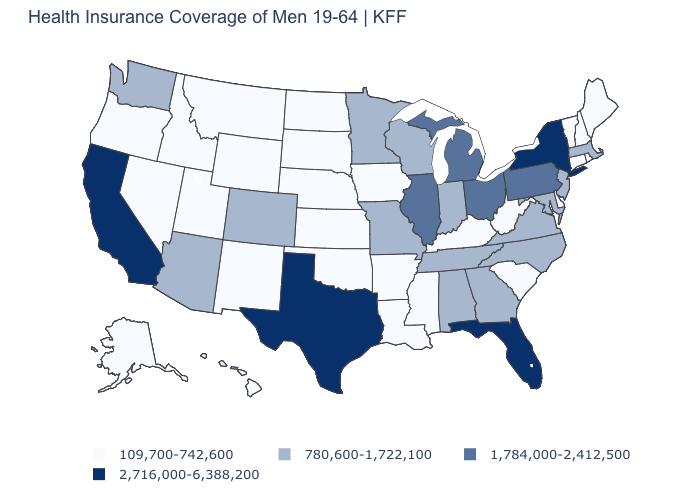Which states hav the highest value in the South?
Concise answer only. Florida, Texas. What is the value of Rhode Island?
Give a very brief answer. 109,700-742,600. How many symbols are there in the legend?
Keep it brief. 4. What is the value of Michigan?
Concise answer only. 1,784,000-2,412,500. Name the states that have a value in the range 109,700-742,600?
Concise answer only. Alaska, Arkansas, Connecticut, Delaware, Hawaii, Idaho, Iowa, Kansas, Kentucky, Louisiana, Maine, Mississippi, Montana, Nebraska, Nevada, New Hampshire, New Mexico, North Dakota, Oklahoma, Oregon, Rhode Island, South Carolina, South Dakota, Utah, Vermont, West Virginia, Wyoming. What is the value of Kansas?
Be succinct. 109,700-742,600. Name the states that have a value in the range 780,600-1,722,100?
Write a very short answer. Alabama, Arizona, Colorado, Georgia, Indiana, Maryland, Massachusetts, Minnesota, Missouri, New Jersey, North Carolina, Tennessee, Virginia, Washington, Wisconsin. What is the value of Ohio?
Short answer required. 1,784,000-2,412,500. Is the legend a continuous bar?
Concise answer only. No. Name the states that have a value in the range 109,700-742,600?
Give a very brief answer. Alaska, Arkansas, Connecticut, Delaware, Hawaii, Idaho, Iowa, Kansas, Kentucky, Louisiana, Maine, Mississippi, Montana, Nebraska, Nevada, New Hampshire, New Mexico, North Dakota, Oklahoma, Oregon, Rhode Island, South Carolina, South Dakota, Utah, Vermont, West Virginia, Wyoming. What is the value of North Dakota?
Be succinct. 109,700-742,600. Does the first symbol in the legend represent the smallest category?
Short answer required. Yes. What is the value of Colorado?
Answer briefly. 780,600-1,722,100. Name the states that have a value in the range 780,600-1,722,100?
Concise answer only. Alabama, Arizona, Colorado, Georgia, Indiana, Maryland, Massachusetts, Minnesota, Missouri, New Jersey, North Carolina, Tennessee, Virginia, Washington, Wisconsin. Does California have the lowest value in the West?
Short answer required. No. 